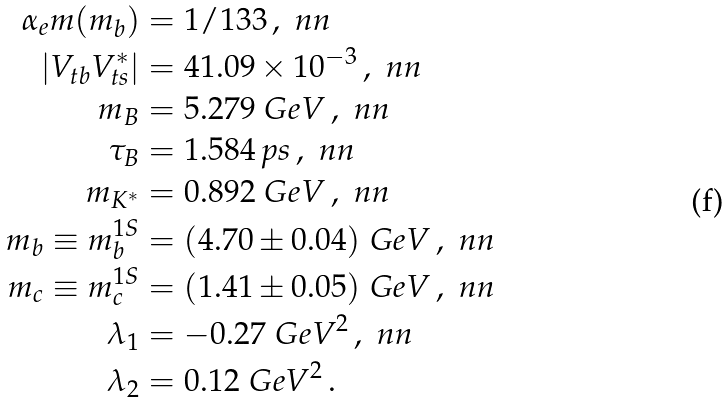Convert formula to latex. <formula><loc_0><loc_0><loc_500><loc_500>\alpha _ { e } m ( m _ { b } ) & = 1 / 1 3 3 \, , \ n n \\ | V _ { t b } V _ { t s } ^ { * } | & = 4 1 . 0 9 \times 1 0 ^ { - 3 } \, , \ n n \\ m _ { B } & = 5 . 2 7 9 \ G e V \, , \ n n \\ \tau _ { B } & = 1 . 5 8 4 \, p s \, , \ n n \\ m _ { K ^ { * } } & = 0 . 8 9 2 \ G e V \, , \ n n \\ m _ { b } \equiv m _ { b } ^ { 1 S } & = ( 4 . 7 0 \pm 0 . 0 4 ) \ G e V \, , \ n n \\ m _ { c } \equiv m _ { c } ^ { 1 S } & = ( 1 . 4 1 \pm 0 . 0 5 ) \ G e V \, , \ n n \\ \lambda _ { 1 } & = - 0 . 2 7 \ G e V ^ { 2 } \, , \ n n \\ \lambda _ { 2 } & = 0 . 1 2 \ G e V ^ { 2 } \, .</formula> 